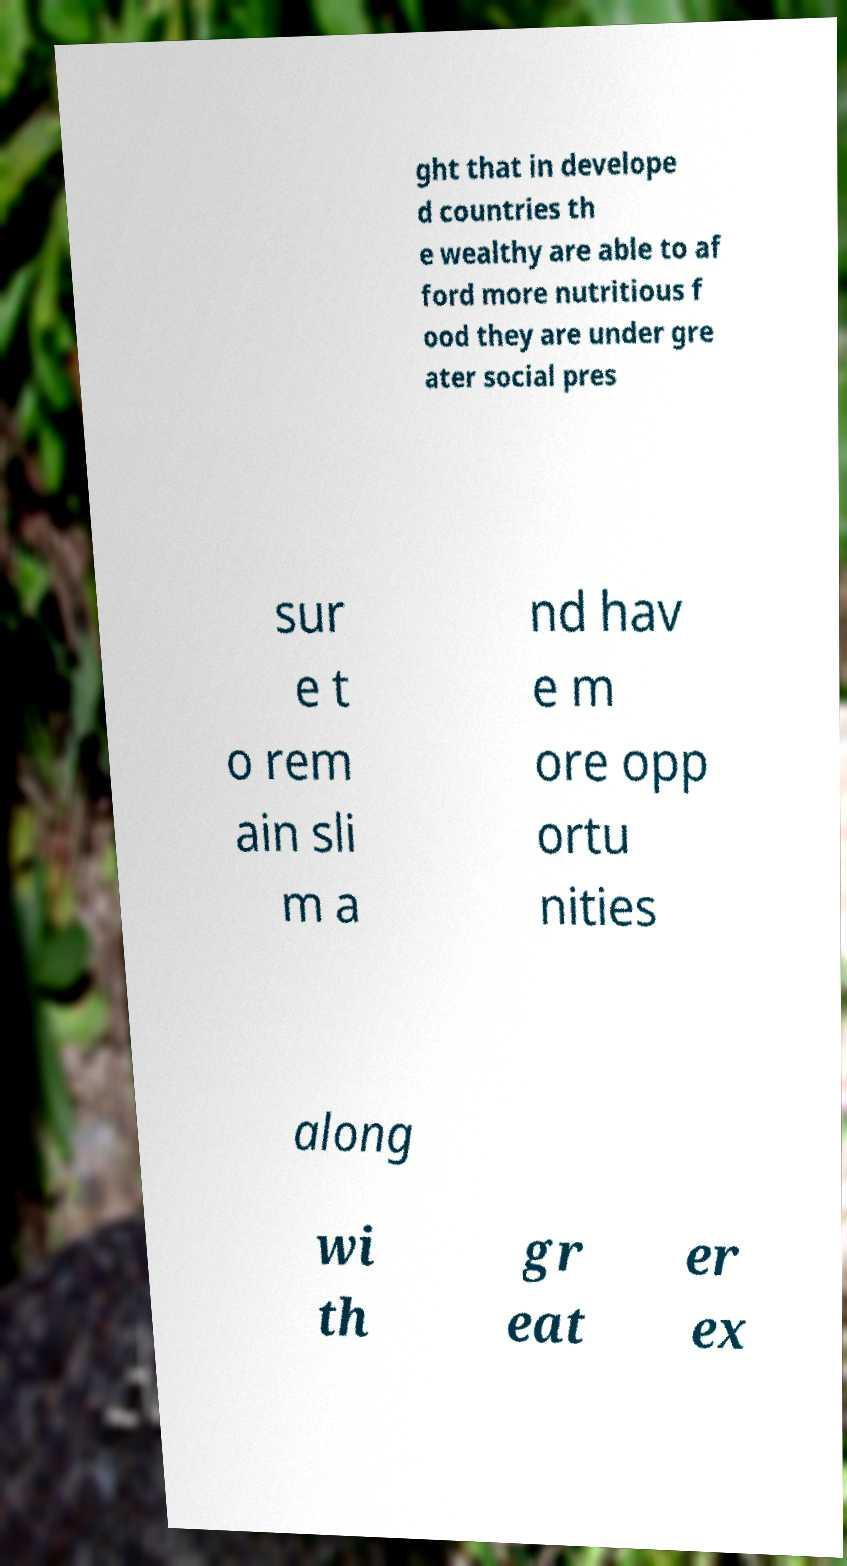I need the written content from this picture converted into text. Can you do that? ght that in develope d countries th e wealthy are able to af ford more nutritious f ood they are under gre ater social pres sur e t o rem ain sli m a nd hav e m ore opp ortu nities along wi th gr eat er ex 